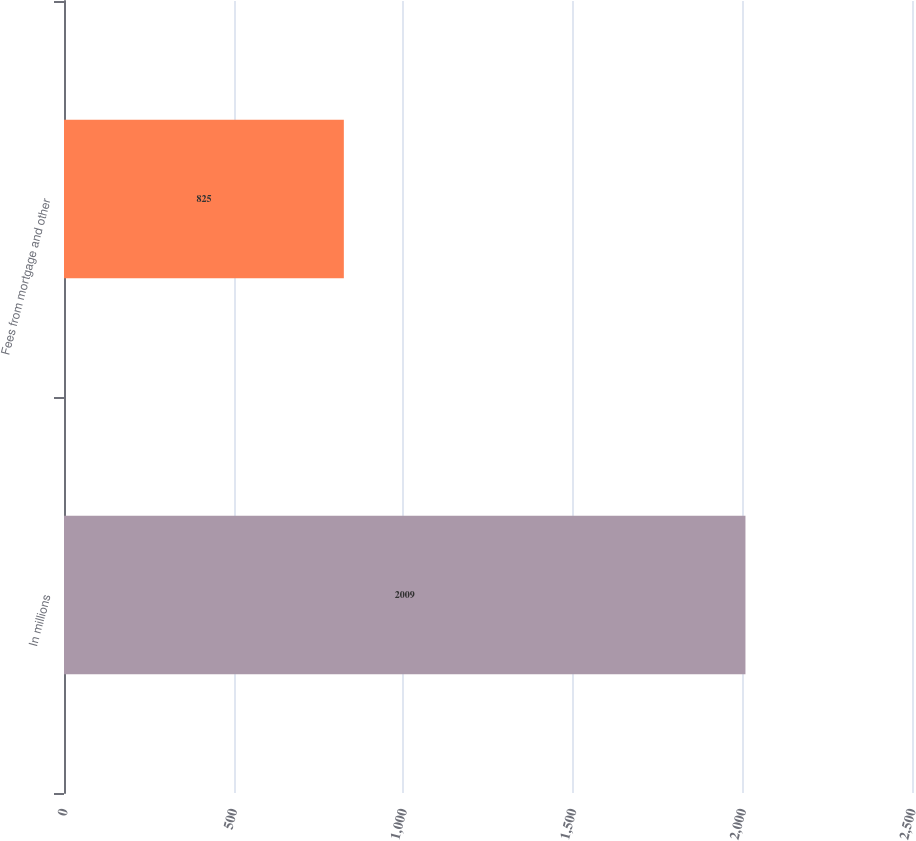Convert chart to OTSL. <chart><loc_0><loc_0><loc_500><loc_500><bar_chart><fcel>In millions<fcel>Fees from mortgage and other<nl><fcel>2009<fcel>825<nl></chart> 